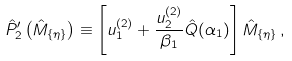Convert formula to latex. <formula><loc_0><loc_0><loc_500><loc_500>\hat { P } ^ { \prime } _ { 2 } \left ( \hat { M } _ { \{ \eta \} } \right ) \equiv \left [ u _ { 1 } ^ { ( 2 ) } + \frac { u _ { 2 } ^ { ( 2 ) } } { \beta _ { 1 } } \hat { Q } ( \alpha _ { 1 } ) \right ] \hat { M } _ { \{ \eta \} } \, ,</formula> 